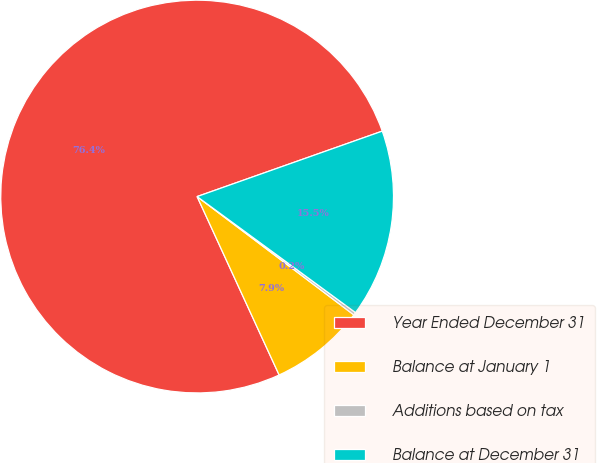<chart> <loc_0><loc_0><loc_500><loc_500><pie_chart><fcel>Year Ended December 31<fcel>Balance at January 1<fcel>Additions based on tax<fcel>Balance at December 31<nl><fcel>76.45%<fcel>7.85%<fcel>0.23%<fcel>15.47%<nl></chart> 